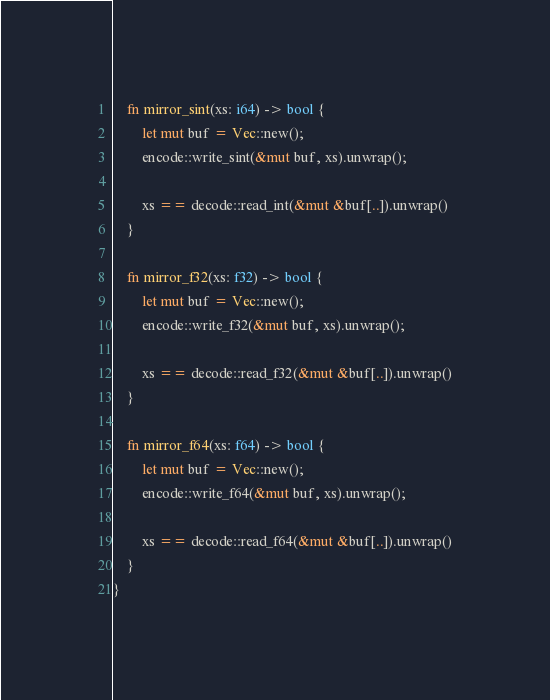Convert code to text. <code><loc_0><loc_0><loc_500><loc_500><_Rust_>
    fn mirror_sint(xs: i64) -> bool {
        let mut buf = Vec::new();
        encode::write_sint(&mut buf, xs).unwrap();

        xs == decode::read_int(&mut &buf[..]).unwrap()
    }

    fn mirror_f32(xs: f32) -> bool {
        let mut buf = Vec::new();
        encode::write_f32(&mut buf, xs).unwrap();

        xs == decode::read_f32(&mut &buf[..]).unwrap()
    }

    fn mirror_f64(xs: f64) -> bool {
        let mut buf = Vec::new();
        encode::write_f64(&mut buf, xs).unwrap();

        xs == decode::read_f64(&mut &buf[..]).unwrap()
    }
}
</code> 